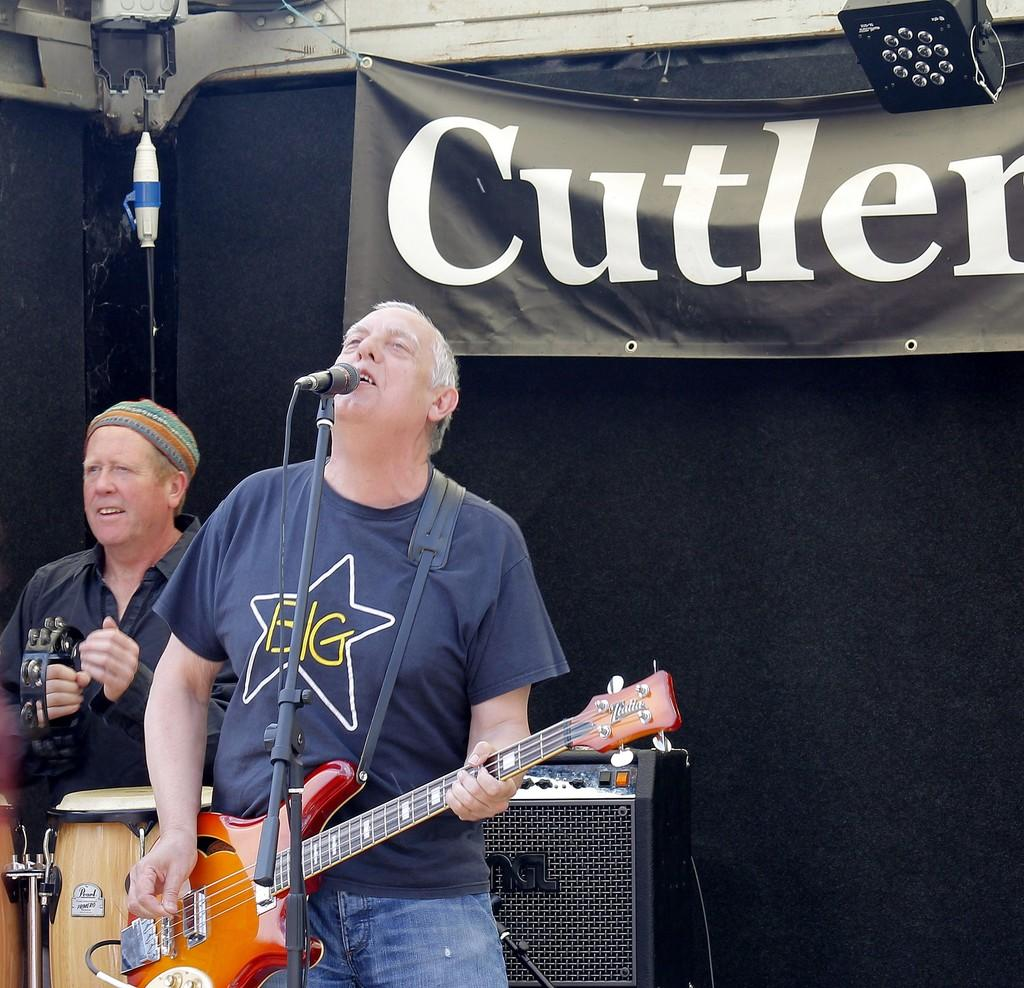What is the man in the image doing? The man is playing guitar and singing on a mic. Are there any other musicians in the image? Yes, there is another man playing a musical instrument. What can be seen in the background of the image? There are two black objects in the background. What type of friction is being generated by the guitar strings in the image? There is no information about the guitar strings or friction in the image, so it cannot be determined. Can you tell me how many hearts are visible in the image? There are no hearts present in the image. 